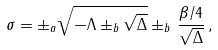<formula> <loc_0><loc_0><loc_500><loc_500>\sigma = \pm _ { a } \sqrt { - \Lambda \pm _ { b } \sqrt { \Delta } } \pm _ { b } \, \frac { \beta / 4 } { \sqrt { \Delta } } \, ,</formula> 